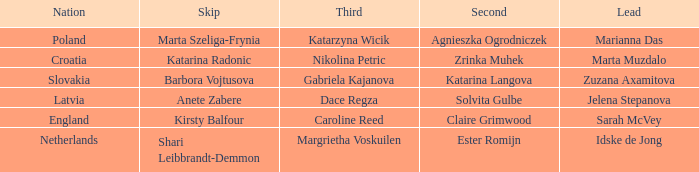Who is the Second with Nikolina Petric as Third? Zrinka Muhek. 